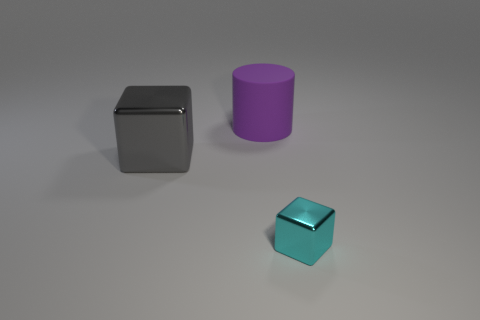Is there any other thing that is the same size as the cyan cube?
Ensure brevity in your answer.  No. How many cylinders are red objects or tiny objects?
Give a very brief answer. 0. There is a cube behind the object that is to the right of the large purple matte cylinder; what is its color?
Ensure brevity in your answer.  Gray. Is the number of large matte things in front of the cyan metal cube less than the number of big rubber things in front of the large metallic object?
Offer a very short reply. No. There is a rubber thing; is it the same size as the shiny cube that is to the right of the big shiny object?
Your response must be concise. No. What is the shape of the object that is behind the cyan thing and in front of the large cylinder?
Make the answer very short. Cube. There is a gray thing that is the same material as the tiny cyan cube; what size is it?
Provide a succinct answer. Large. There is a metal thing that is behind the small cyan shiny block; how many shiny things are in front of it?
Make the answer very short. 1. Is the material of the block on the right side of the large gray metal cube the same as the gray block?
Ensure brevity in your answer.  Yes. Is there anything else that has the same material as the gray thing?
Provide a short and direct response. Yes. 